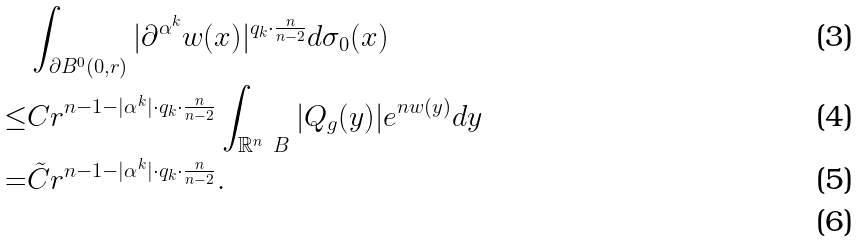Convert formula to latex. <formula><loc_0><loc_0><loc_500><loc_500>& \int _ { \partial B ^ { 0 } ( 0 , r ) } | \partial ^ { \alpha ^ { k } } w ( x ) | ^ { q _ { k } \cdot \frac { n } { n - 2 } } d \sigma _ { 0 } ( x ) \\ \leq & C r ^ { n - 1 - | \alpha ^ { k } | \cdot q _ { k } \cdot \frac { n } { n - 2 } } \int _ { \mathbb { R } ^ { n } \ B } | Q _ { g } ( y ) | e ^ { n w ( y ) } d y \\ = & \tilde { C } r ^ { n - 1 - | \alpha ^ { k } | \cdot q _ { k } \cdot \frac { n } { n - 2 } } . \\</formula> 